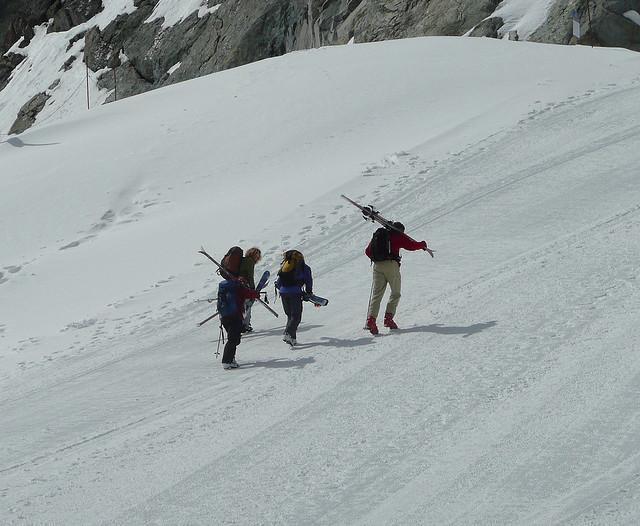How many people are there?
Give a very brief answer. 4. How many people can be seen?
Give a very brief answer. 2. 